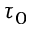Convert formula to latex. <formula><loc_0><loc_0><loc_500><loc_500>\tau _ { 0 }</formula> 